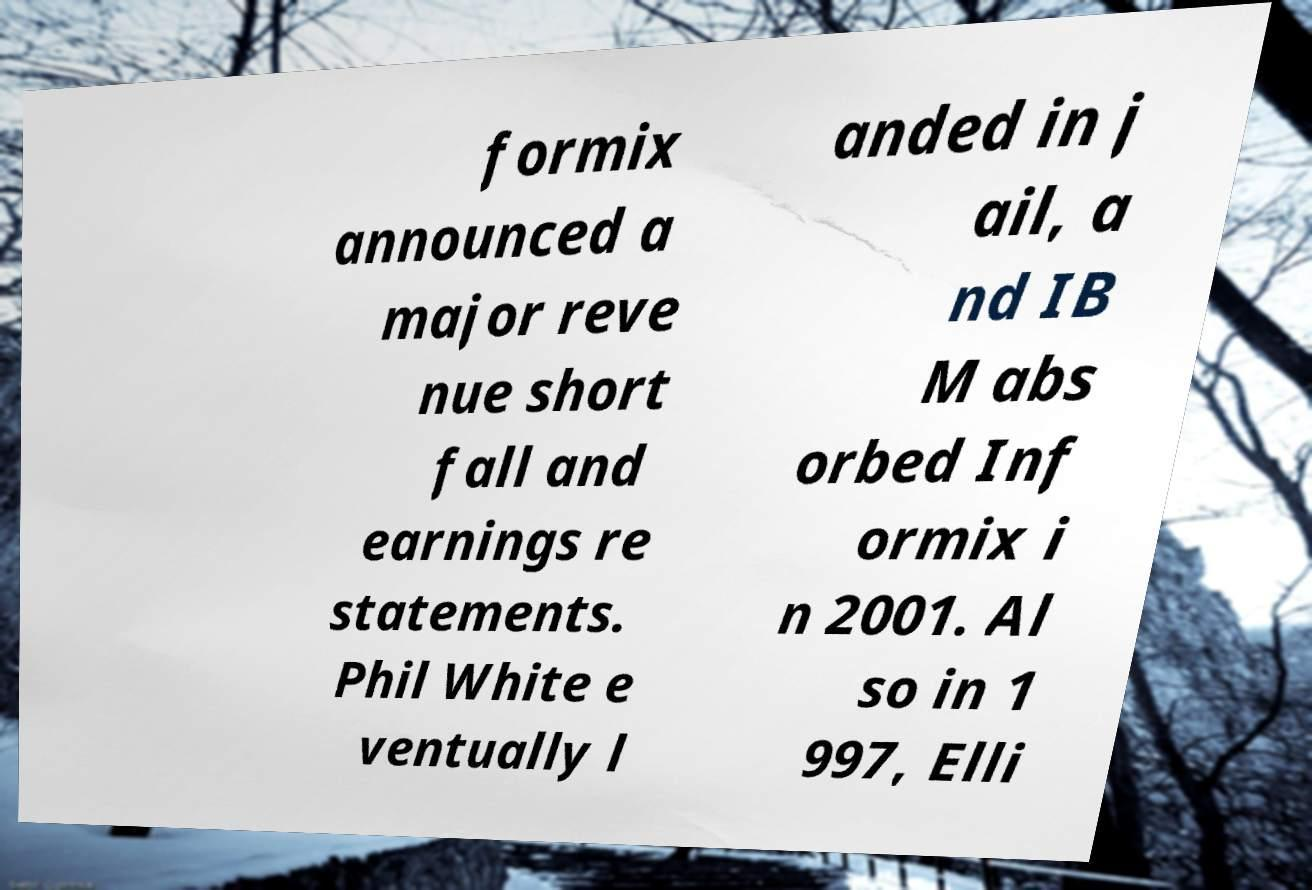Please read and relay the text visible in this image. What does it say? formix announced a major reve nue short fall and earnings re statements. Phil White e ventually l anded in j ail, a nd IB M abs orbed Inf ormix i n 2001. Al so in 1 997, Elli 